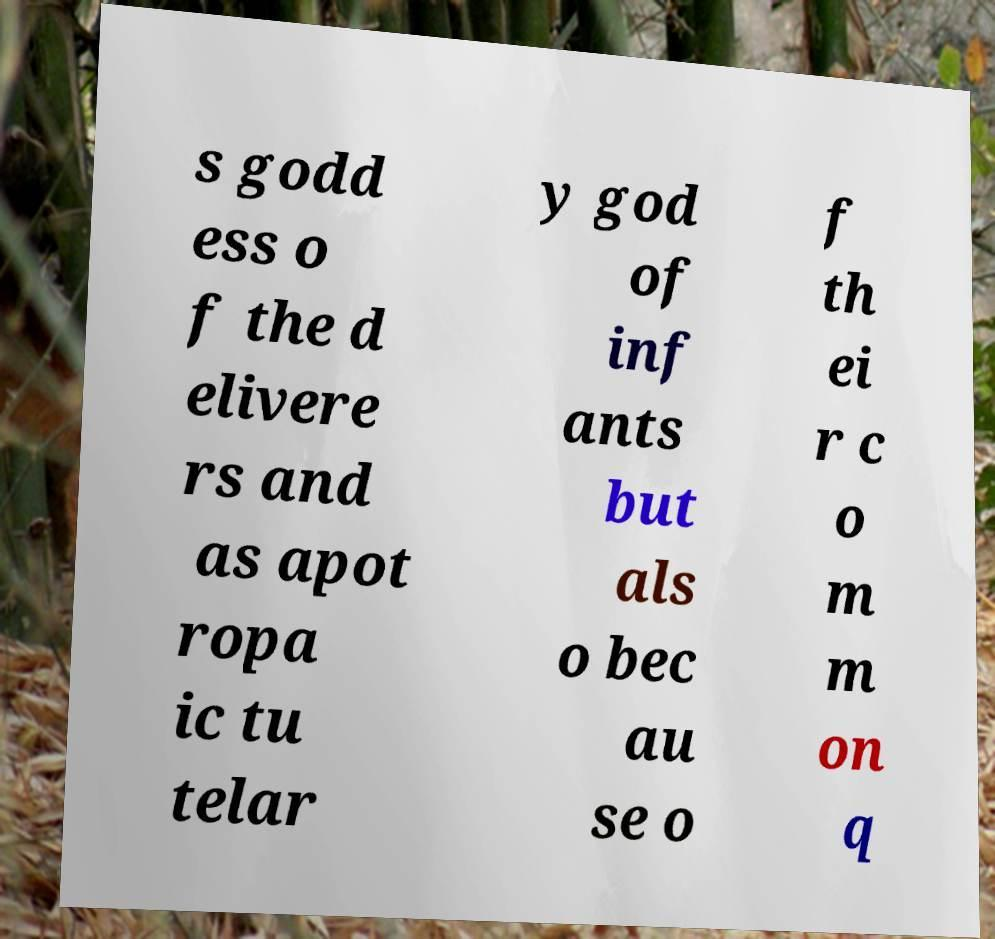For documentation purposes, I need the text within this image transcribed. Could you provide that? s godd ess o f the d elivere rs and as apot ropa ic tu telar y god of inf ants but als o bec au se o f th ei r c o m m on q 